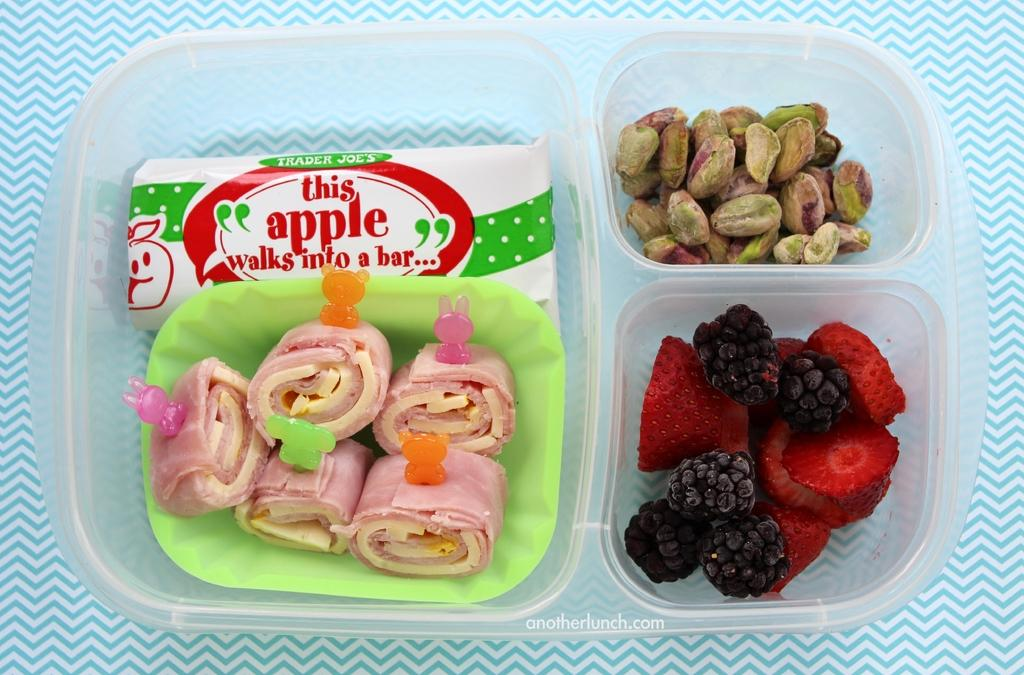What is the main subject of the image? The main subject of the image is food. How is the food contained in the image? The food is in a box. Where is the box located in the image? The box is in the center of the image. What else can be found inside the box? There is a paper object in the box. What is written on the paper object? The paper object has text written on it. What type of music can be heard playing in the background of the image? There is no music or audio present in the image, as it is a still photograph. 